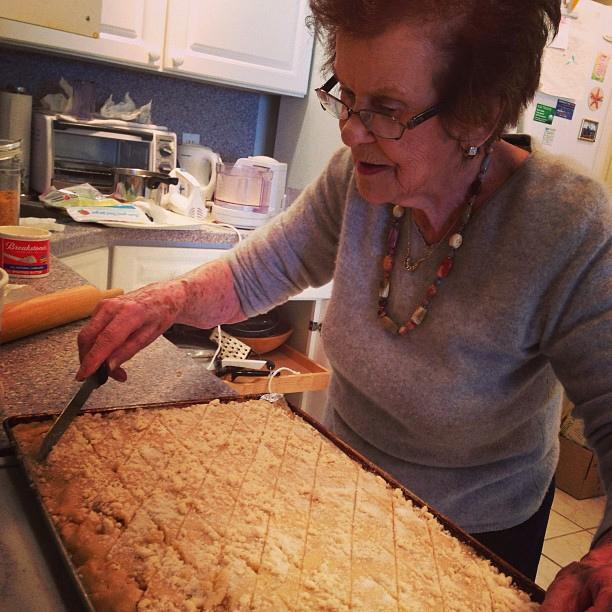What is the woman doing to her cake? Please explain your reasoning. cross hatching. That's what the process is called. 